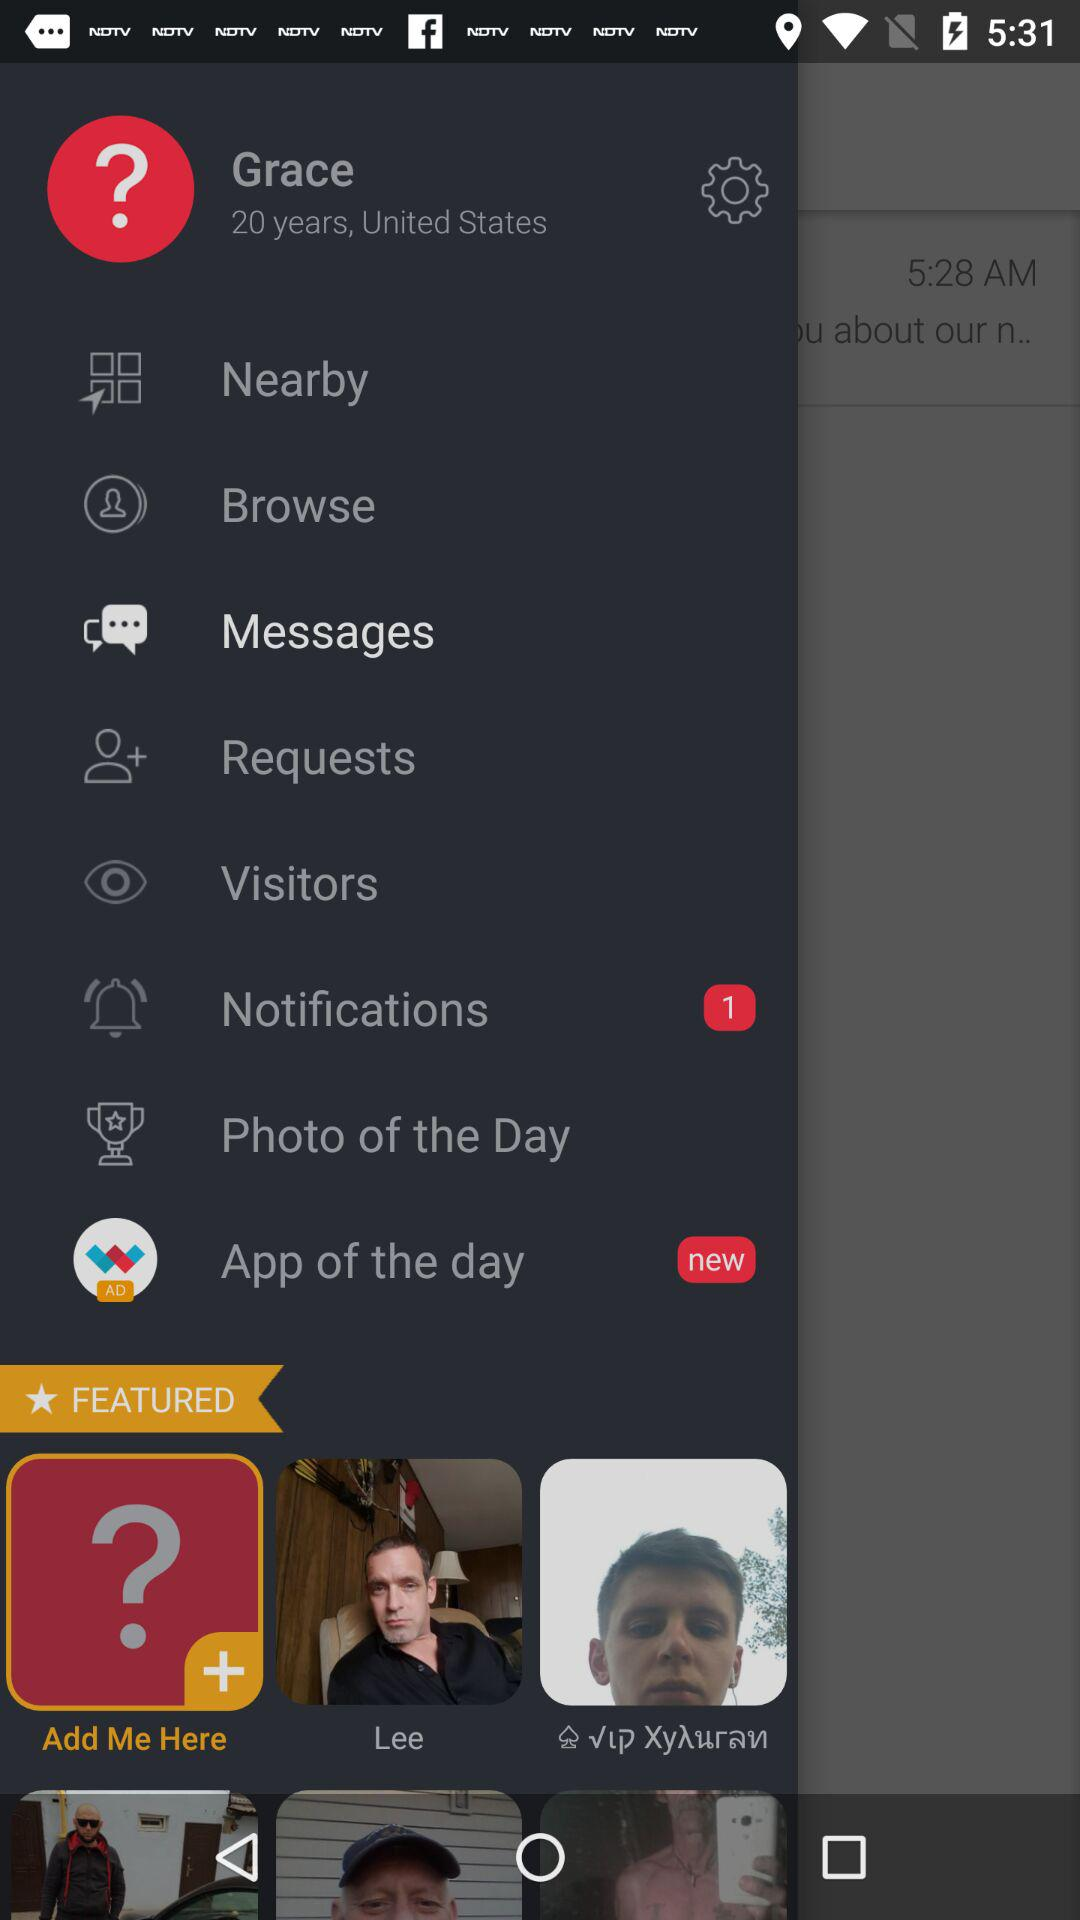How old is the user? The user is 20 years old. 